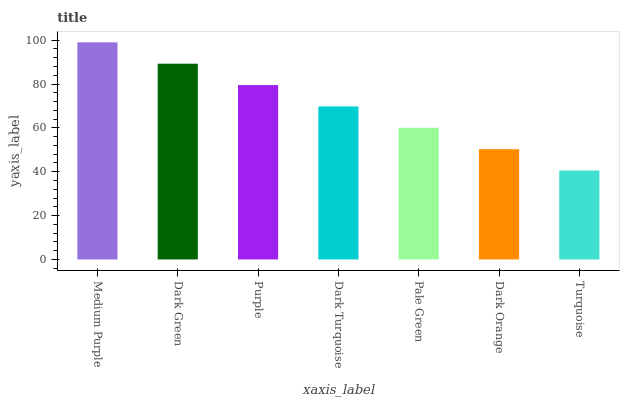Is Turquoise the minimum?
Answer yes or no. Yes. Is Medium Purple the maximum?
Answer yes or no. Yes. Is Dark Green the minimum?
Answer yes or no. No. Is Dark Green the maximum?
Answer yes or no. No. Is Medium Purple greater than Dark Green?
Answer yes or no. Yes. Is Dark Green less than Medium Purple?
Answer yes or no. Yes. Is Dark Green greater than Medium Purple?
Answer yes or no. No. Is Medium Purple less than Dark Green?
Answer yes or no. No. Is Dark Turquoise the high median?
Answer yes or no. Yes. Is Dark Turquoise the low median?
Answer yes or no. Yes. Is Medium Purple the high median?
Answer yes or no. No. Is Dark Green the low median?
Answer yes or no. No. 